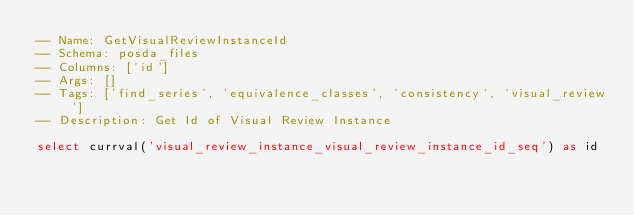Convert code to text. <code><loc_0><loc_0><loc_500><loc_500><_SQL_>-- Name: GetVisualReviewInstanceId
-- Schema: posda_files
-- Columns: ['id']
-- Args: []
-- Tags: ['find_series', 'equivalence_classes', 'consistency', 'visual_review']
-- Description: Get Id of Visual Review Instance

select currval('visual_review_instance_visual_review_instance_id_seq') as id</code> 